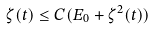Convert formula to latex. <formula><loc_0><loc_0><loc_500><loc_500>\zeta ( t ) \leq C ( E _ { 0 } + \zeta ^ { 2 } ( t ) )</formula> 